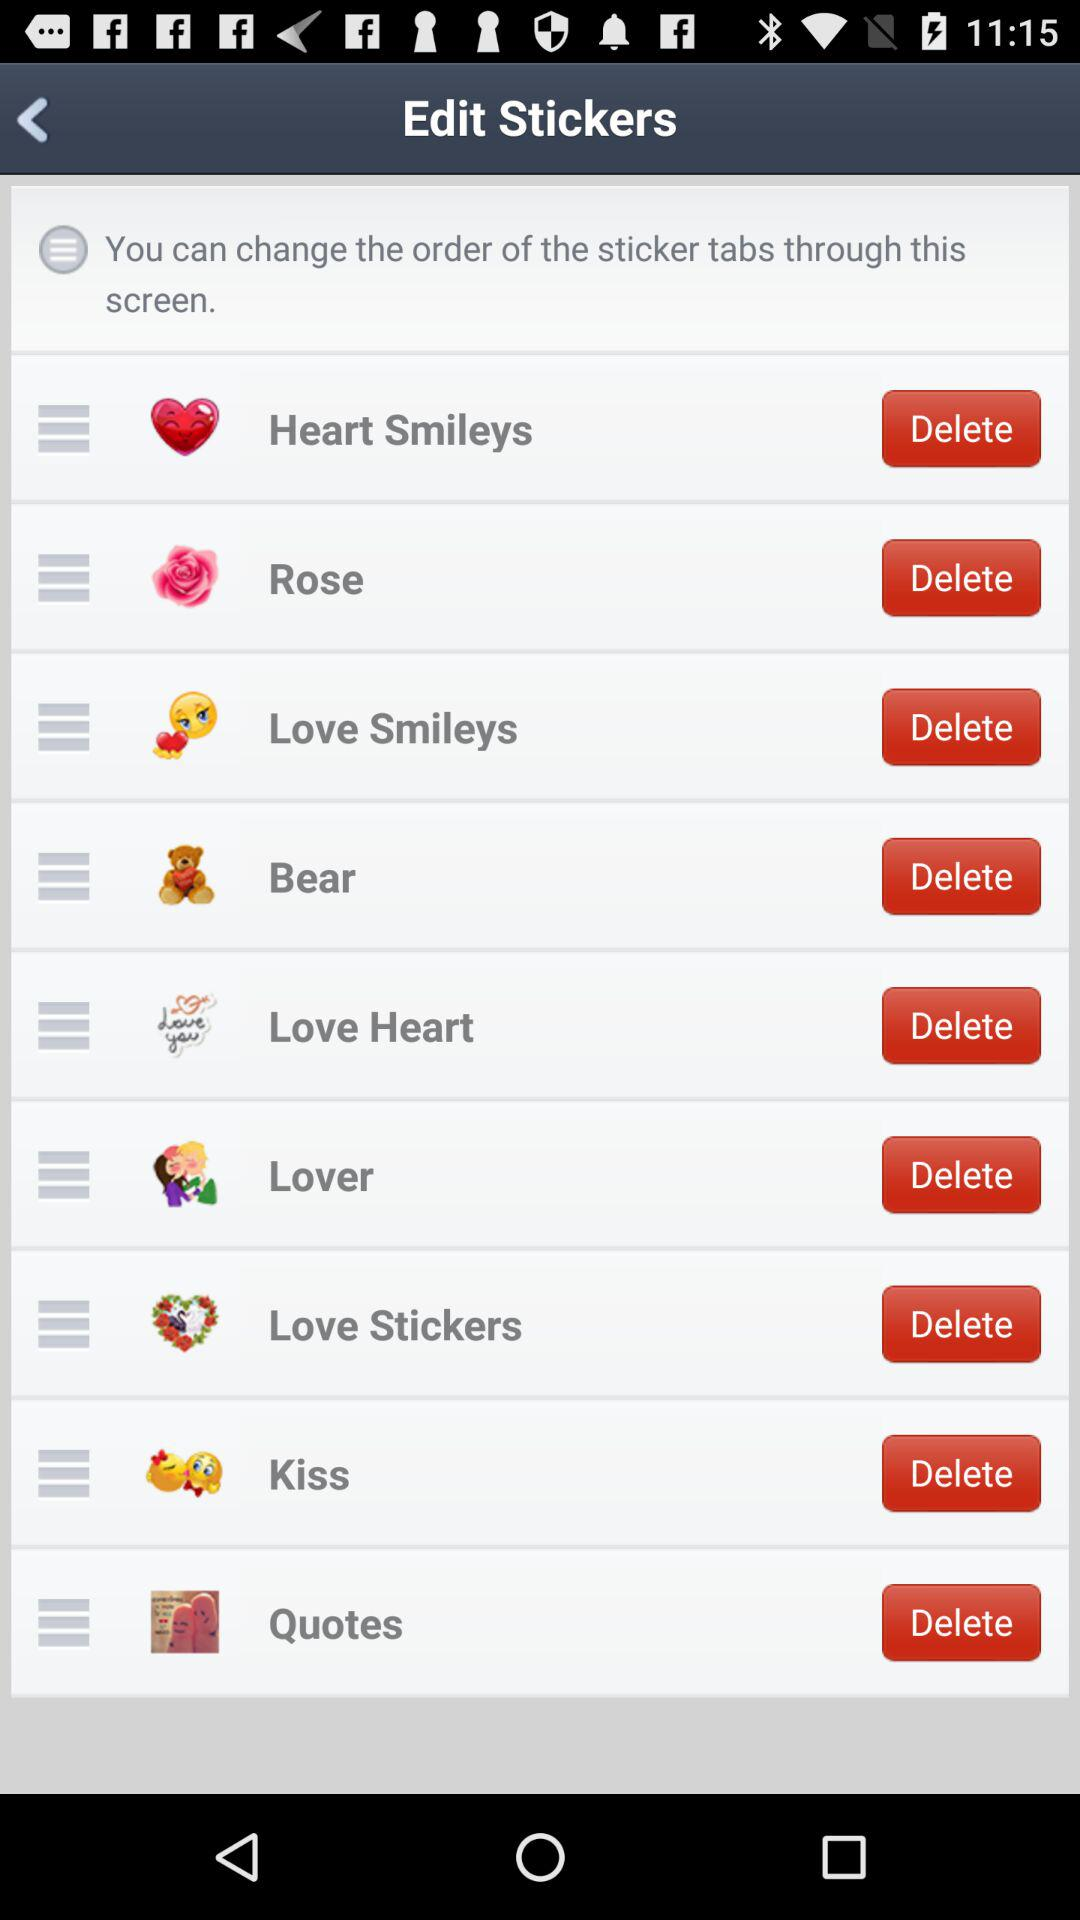How many of the tabs have a heart emoji?
Answer the question using a single word or phrase. 4 